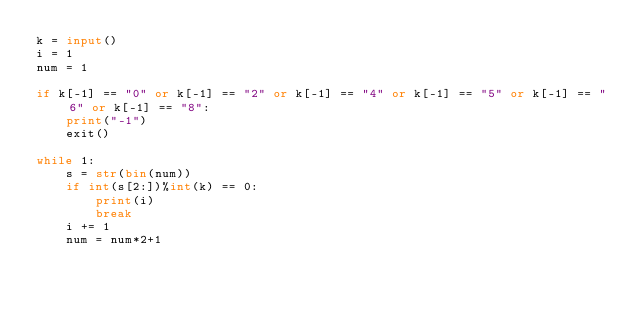<code> <loc_0><loc_0><loc_500><loc_500><_Python_>k = input()
i = 1
num = 1

if k[-1] == "0" or k[-1] == "2" or k[-1] == "4" or k[-1] == "5" or k[-1] == "6" or k[-1] == "8":
    print("-1")
    exit()

while 1:
    s = str(bin(num))
    if int(s[2:])%int(k) == 0:
        print(i)
        break
    i += 1
    num = num*2+1</code> 